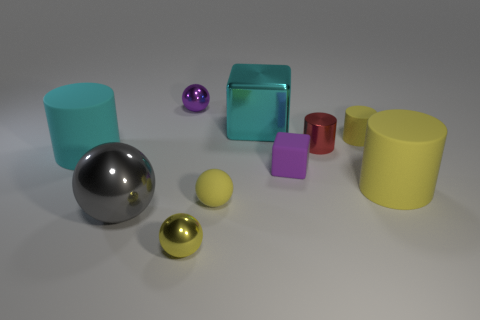Subtract all gray blocks. How many yellow balls are left? 2 Subtract all purple balls. How many balls are left? 3 Subtract all red cylinders. How many cylinders are left? 3 Subtract all brown cylinders. Subtract all blue blocks. How many cylinders are left? 4 Subtract all blocks. How many objects are left? 8 Add 9 big purple objects. How many big purple objects exist? 9 Subtract 0 brown cubes. How many objects are left? 10 Subtract all big cyan things. Subtract all purple rubber things. How many objects are left? 7 Add 2 red shiny things. How many red shiny things are left? 3 